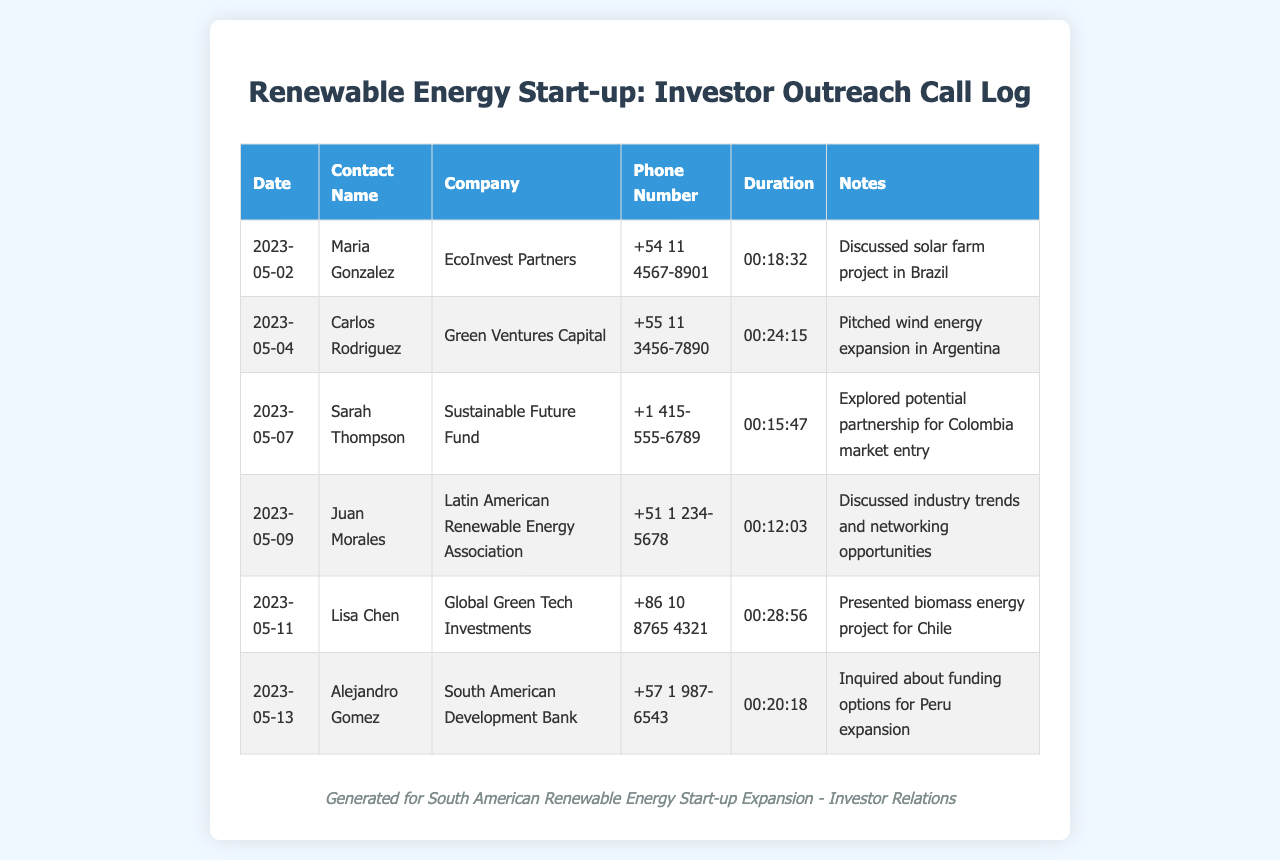What is the date of the first call made? The date of the first call is listed in the document, which is 2023-05-02.
Answer: 2023-05-02 Who is the contact name for EcoInvest Partners? The contact name associated with EcoInvest Partners is shown in the document as Maria Gonzalez.
Answer: Maria Gonzalez What was the duration of the call with Lisa Chen? The duration of the call with Lisa Chen is specified as 00:28:56 in the document.
Answer: 00:28:56 Which company did Alejandro Gomez represent? The company represented by Alejandro Gomez is identified in the document as South American Development Bank.
Answer: South American Development Bank How many minutes did the call with Sarah Thompson last? The duration of the call with Sarah Thompson must be converted from the document, which shows it as 00:15:47, equivalent to 15 minutes and 47 seconds.
Answer: 15 minutes 47 seconds Which country is mentioned in the context of a solar farm project? The document indicates the discussion of a solar farm project relates to the country of Brazil.
Answer: Brazil What was discussed during the call with Juan Morales? The notes for the call with Juan Morales indicate discussions about industry trends and networking opportunities.
Answer: Industry trends and networking opportunities Which contact had the longest call duration? The longest call duration in the document is associated with Lisa Chen.
Answer: Lisa Chen What was the subject of discussion in the call with Carlos Rodriguez? The subject discussed with Carlos Rodriguez involved a pitch for wind energy expansion in Argentina.
Answer: Wind energy expansion in Argentina 